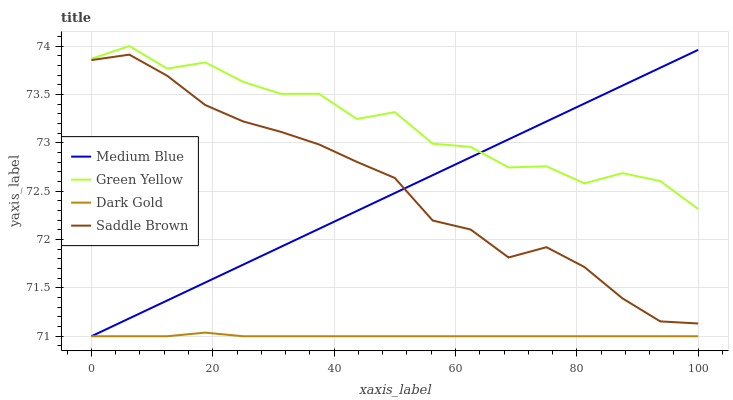Does Dark Gold have the minimum area under the curve?
Answer yes or no. Yes. Does Green Yellow have the maximum area under the curve?
Answer yes or no. Yes. Does Medium Blue have the minimum area under the curve?
Answer yes or no. No. Does Medium Blue have the maximum area under the curve?
Answer yes or no. No. Is Medium Blue the smoothest?
Answer yes or no. Yes. Is Green Yellow the roughest?
Answer yes or no. Yes. Is Saddle Brown the smoothest?
Answer yes or no. No. Is Saddle Brown the roughest?
Answer yes or no. No. Does Medium Blue have the lowest value?
Answer yes or no. Yes. Does Saddle Brown have the lowest value?
Answer yes or no. No. Does Green Yellow have the highest value?
Answer yes or no. Yes. Does Medium Blue have the highest value?
Answer yes or no. No. Is Dark Gold less than Saddle Brown?
Answer yes or no. Yes. Is Green Yellow greater than Saddle Brown?
Answer yes or no. Yes. Does Medium Blue intersect Green Yellow?
Answer yes or no. Yes. Is Medium Blue less than Green Yellow?
Answer yes or no. No. Is Medium Blue greater than Green Yellow?
Answer yes or no. No. Does Dark Gold intersect Saddle Brown?
Answer yes or no. No. 